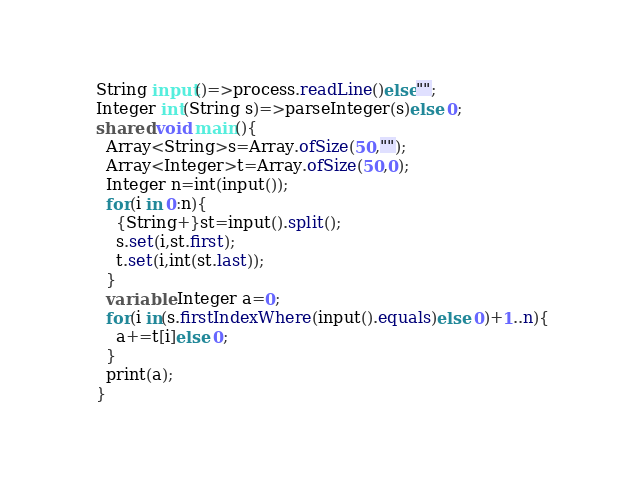<code> <loc_0><loc_0><loc_500><loc_500><_Ceylon_>String input()=>process.readLine()else""; 
Integer int(String s)=>parseInteger(s)else 0;
shared void main(){
  Array<String>s=Array.ofSize(50,"");
  Array<Integer>t=Array.ofSize(50,0);
  Integer n=int(input());
  for(i in 0:n){
    {String+}st=input().split();
    s.set(i,st.first);
    t.set(i,int(st.last));
  }
  variable Integer a=0;
  for(i in(s.firstIndexWhere(input().equals)else 0)+1..n){
    a+=t[i]else 0;
  }
  print(a);
}
</code> 